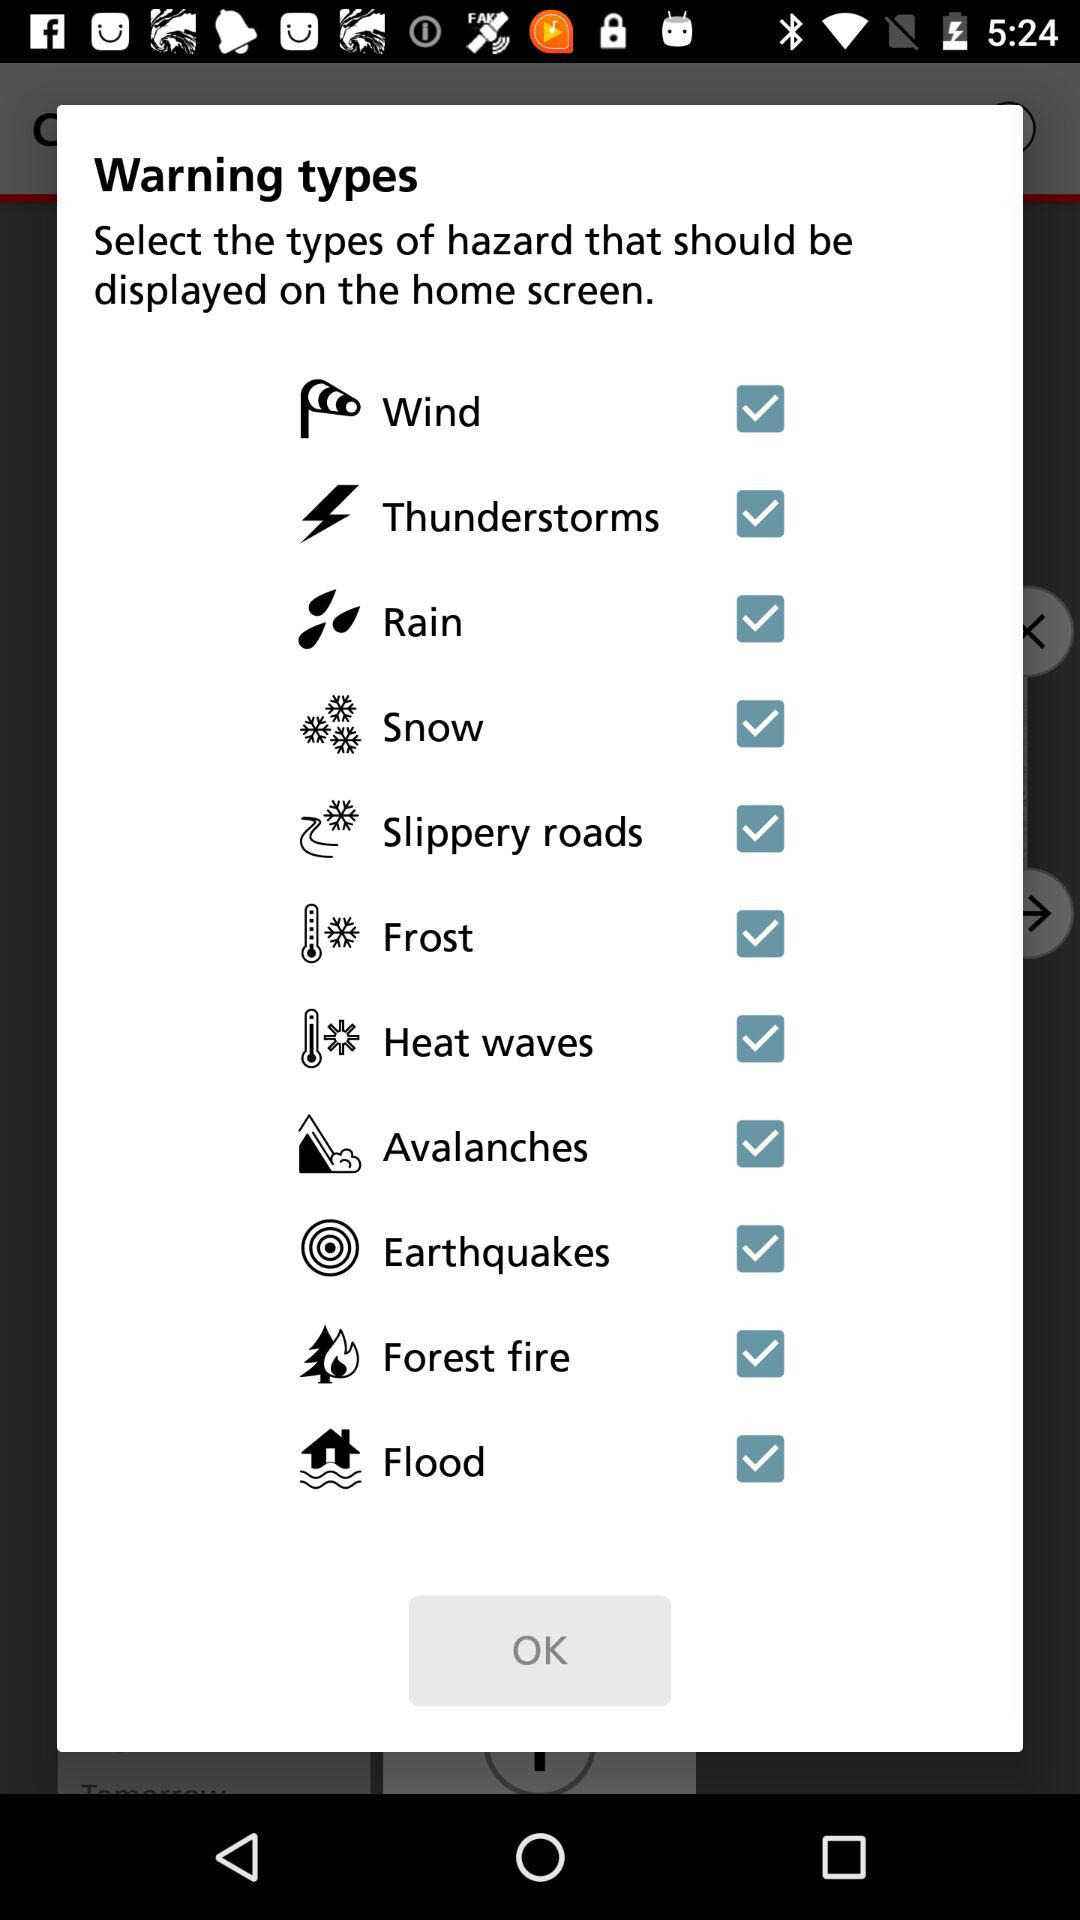Is Flood selected or not?
When the provided information is insufficient, respond with <no answer>. <no answer> 